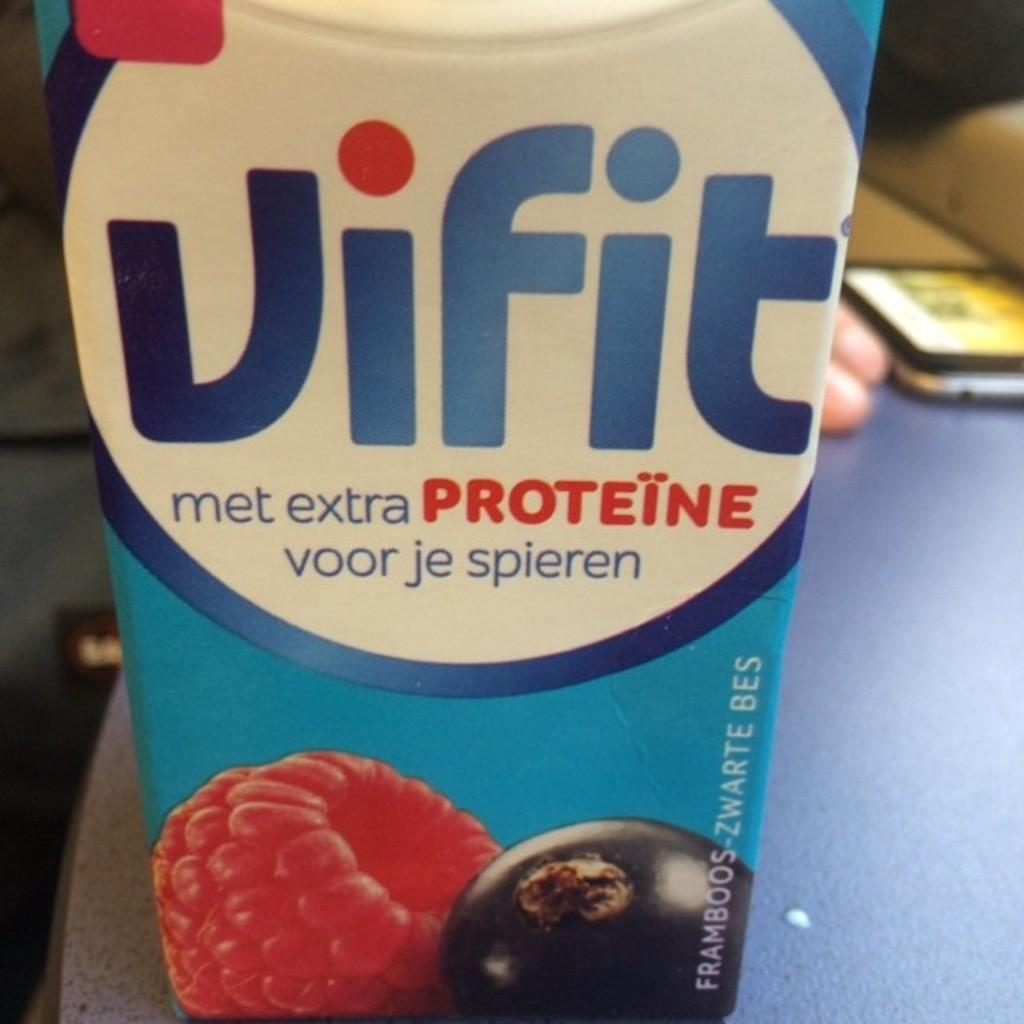<image>
Create a compact narrative representing the image presented. A drink carton says "met extra PROTEINE" and has pictures of berries on it. 